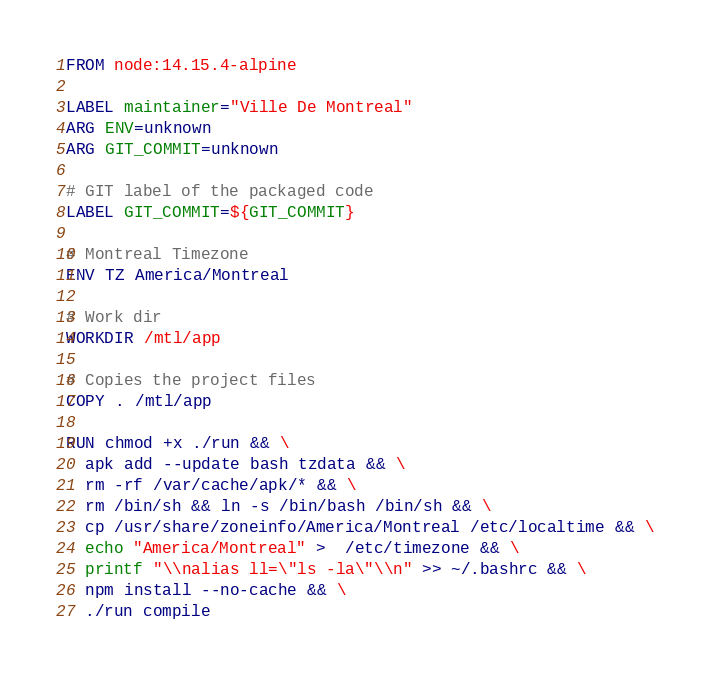Convert code to text. <code><loc_0><loc_0><loc_500><loc_500><_Dockerfile_>FROM node:14.15.4-alpine

LABEL maintainer="Ville De Montreal"
ARG ENV=unknown
ARG GIT_COMMIT=unknown

# GIT label of the packaged code
LABEL GIT_COMMIT=${GIT_COMMIT}

# Montreal Timezone 
ENV TZ America/Montreal

# Work dir
WORKDIR /mtl/app

# Copies the project files
COPY . /mtl/app

RUN chmod +x ./run && \
  apk add --update bash tzdata && \
  rm -rf /var/cache/apk/* && \
  rm /bin/sh && ln -s /bin/bash /bin/sh && \
  cp /usr/share/zoneinfo/America/Montreal /etc/localtime && \
  echo "America/Montreal" >  /etc/timezone && \
  printf "\\nalias ll=\"ls -la\"\\n" >> ~/.bashrc && \
  npm install --no-cache && \
  ./run compile
</code> 